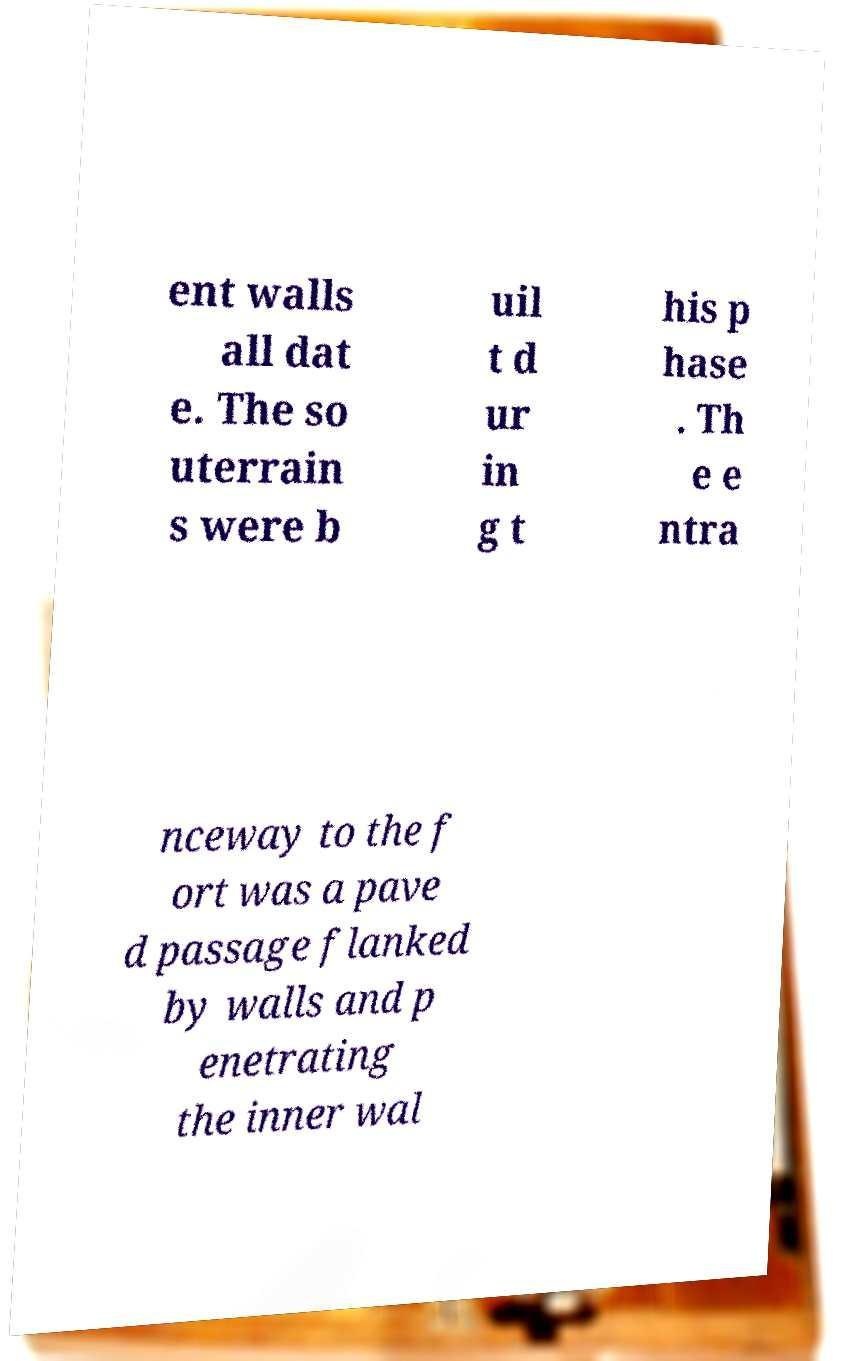Can you read and provide the text displayed in the image?This photo seems to have some interesting text. Can you extract and type it out for me? ent walls all dat e. The so uterrain s were b uil t d ur in g t his p hase . Th e e ntra nceway to the f ort was a pave d passage flanked by walls and p enetrating the inner wal 